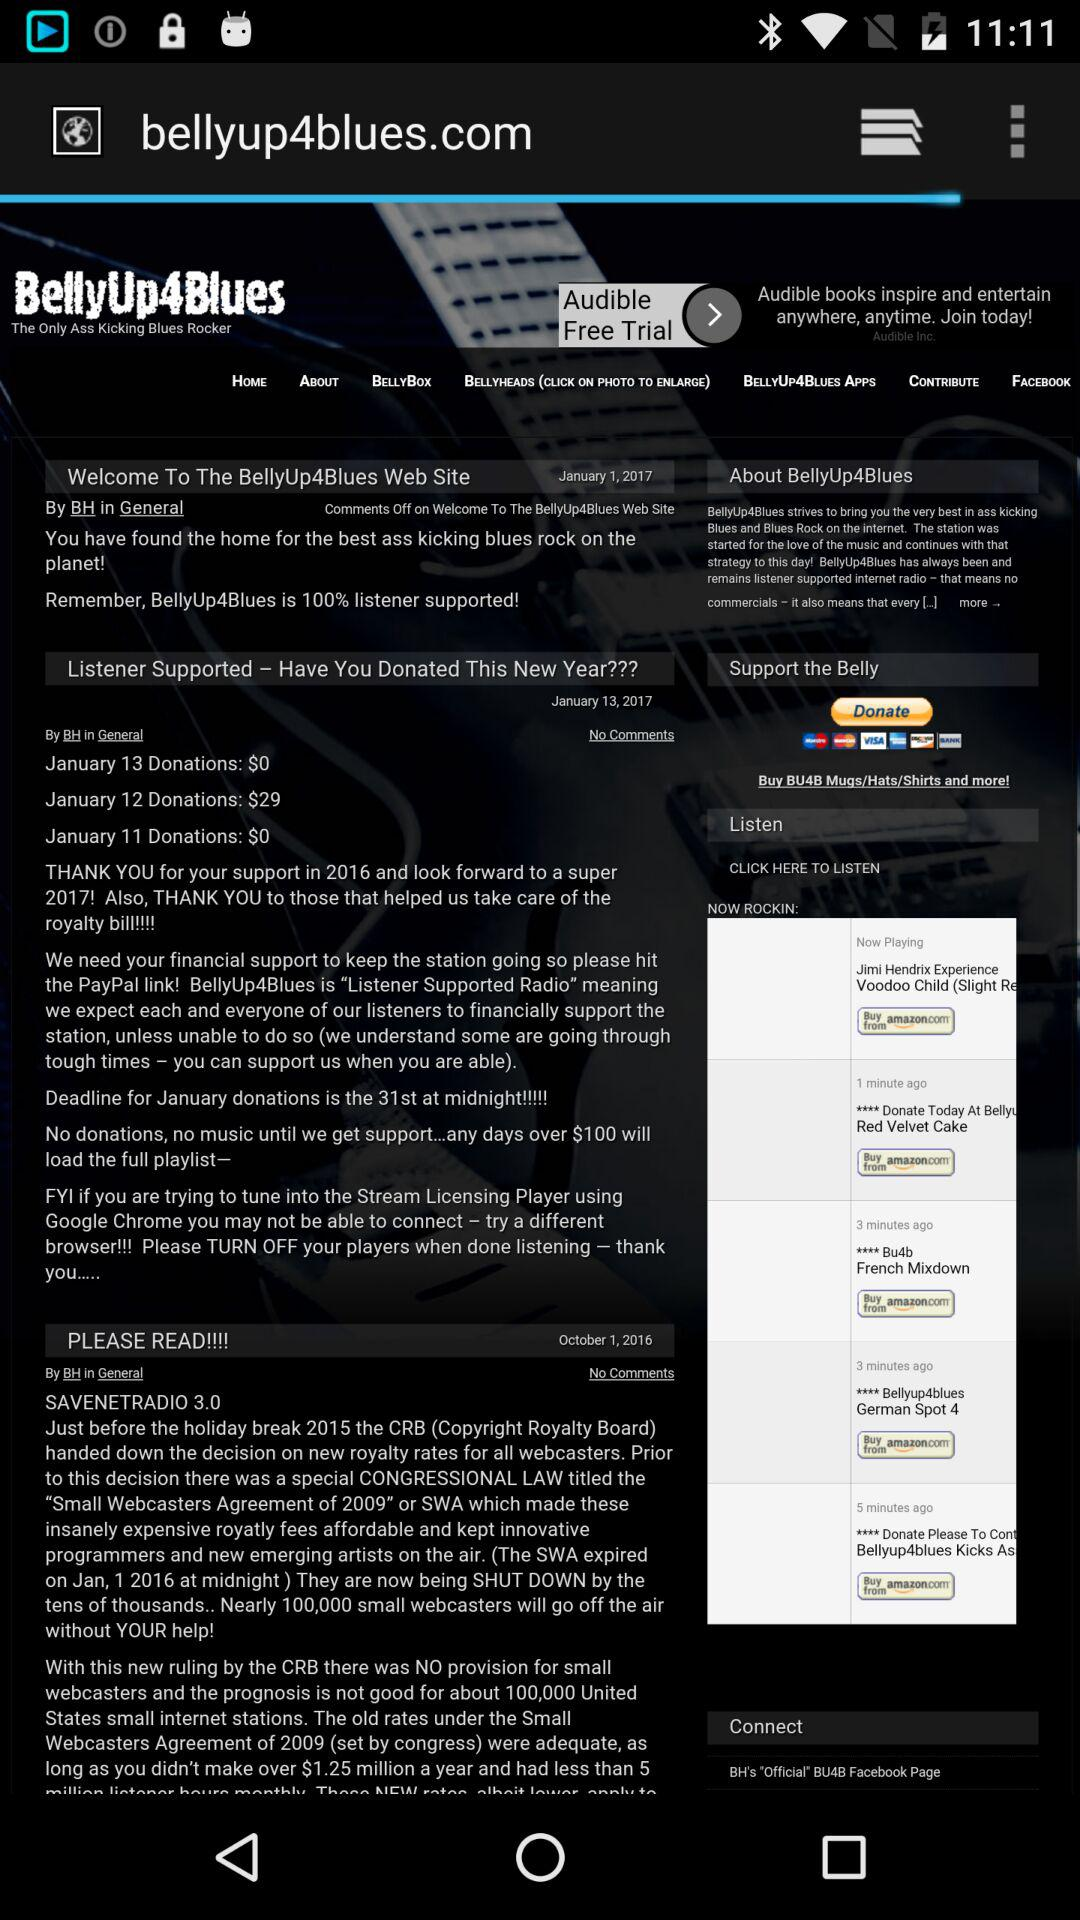What is the name of the application? The name of the application is "BellyUp4Blues". 